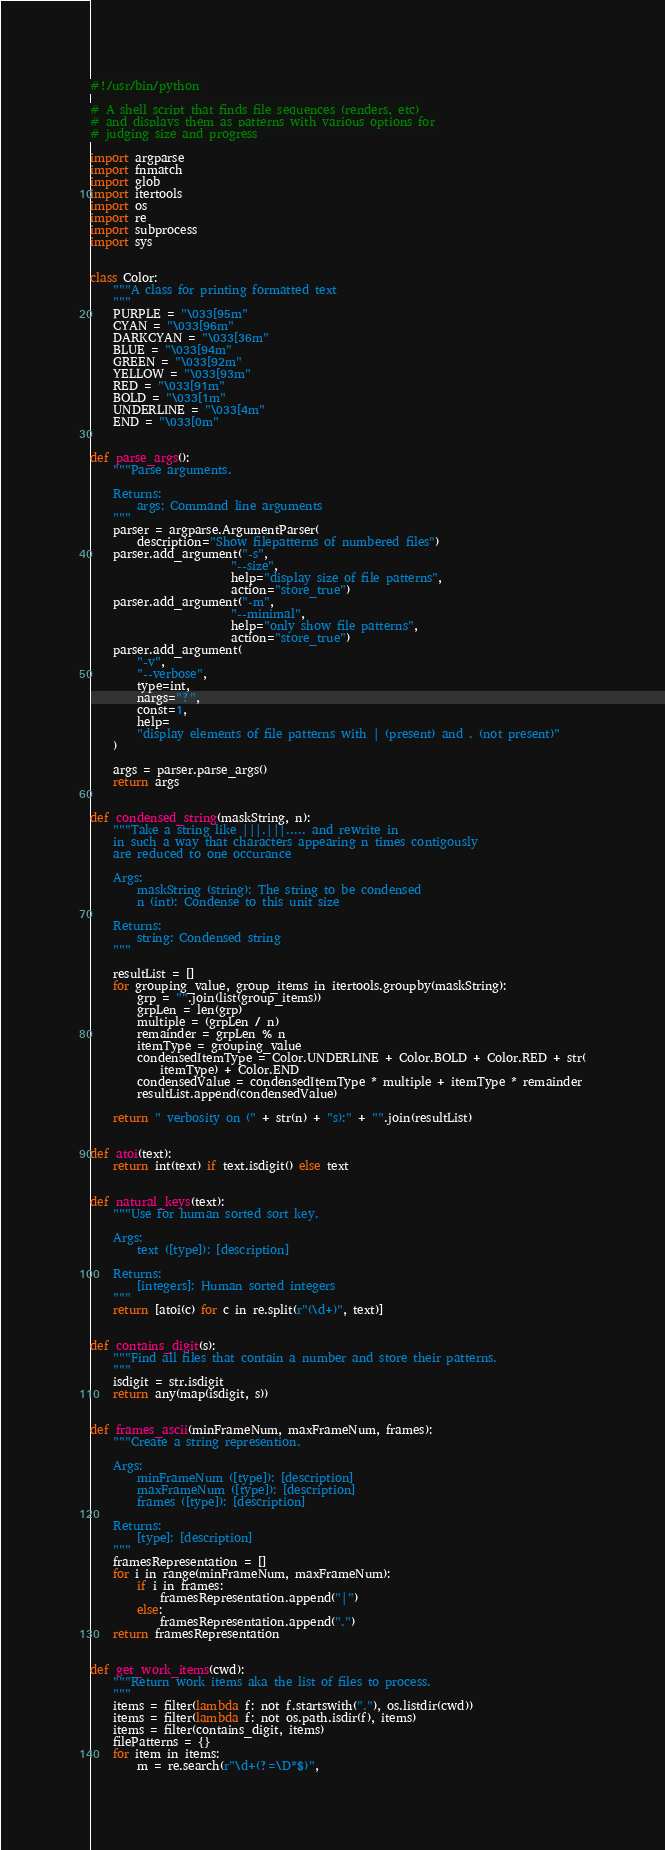Convert code to text. <code><loc_0><loc_0><loc_500><loc_500><_Python_>#!/usr/bin/python

# A shell script that finds file sequences (renders, etc)
# and displays them as patterns with various options for
# judging size and progress

import argparse
import fnmatch
import glob
import itertools
import os
import re
import subprocess
import sys


class Color:
    """A class for printing formatted text
    """
    PURPLE = "\033[95m"
    CYAN = "\033[96m"
    DARKCYAN = "\033[36m"
    BLUE = "\033[94m"
    GREEN = "\033[92m"
    YELLOW = "\033[93m"
    RED = "\033[91m"
    BOLD = "\033[1m"
    UNDERLINE = "\033[4m"
    END = "\033[0m"


def parse_args():
    """Parse arguments.

    Returns:
        args: Command line arguments
    """
    parser = argparse.ArgumentParser(
        description="Show filepatterns of numbered files")
    parser.add_argument("-s",
                        "--size",
                        help="display size of file patterns",
                        action="store_true")
    parser.add_argument("-m",
                        "--minimal",
                        help="only show file patterns",
                        action="store_true")
    parser.add_argument(
        "-v",
        "--verbose",
        type=int,
        nargs="?",
        const=1,
        help=
        "display elements of file patterns with | (present) and . (not present)"
    )

    args = parser.parse_args()
    return args


def condensed_string(maskString, n):
    """Take a string like |||.|||..... and rewrite in
    in such a way that characters appearing n times contigously
    are reduced to one occurance

    Args:
        maskString (string): The string to be condensed
        n (int): Condense to this unit size

    Returns:
        string: Condensed string
    """

    resultList = []
    for grouping_value, group_items in itertools.groupby(maskString):
        grp = "".join(list(group_items))
        grpLen = len(grp)
        multiple = (grpLen / n)
        remainder = grpLen % n
        itemType = grouping_value
        condensedItemType = Color.UNDERLINE + Color.BOLD + Color.RED + str(
            itemType) + Color.END
        condensedValue = condensedItemType * multiple + itemType * remainder
        resultList.append(condensedValue)

    return " verbosity on (" + str(n) + "s):" + "".join(resultList)


def atoi(text):
    return int(text) if text.isdigit() else text


def natural_keys(text):
    """Use for human sorted sort key. 

    Args:
        text ([type]): [description]

    Returns:
        [integers]: Human sorted integers
    """
    return [atoi(c) for c in re.split(r"(\d+)", text)]


def contains_digit(s):
    """Find all files that contain a number and store their patterns.
    """
    isdigit = str.isdigit
    return any(map(isdigit, s))


def frames_ascii(minFrameNum, maxFrameNum, frames):
    """Create a string represention.

    Args:
        minFrameNum ([type]): [description]
        maxFrameNum ([type]): [description]
        frames ([type]): [description]

    Returns:
        [type]: [description]
    """    
    framesRepresentation = []
    for i in range(minFrameNum, maxFrameNum):
        if i in frames:
            framesRepresentation.append("|")
        else:
            framesRepresentation.append(".")
    return framesRepresentation


def get_work_items(cwd):
    """Return work items aka the list of files to process.
    """
    items = filter(lambda f: not f.startswith("."), os.listdir(cwd))
    items = filter(lambda f: not os.path.isdir(f), items)
    items = filter(contains_digit, items)
    filePatterns = {}
    for item in items:
        m = re.search(r"\d+(?=\D*$)",</code> 